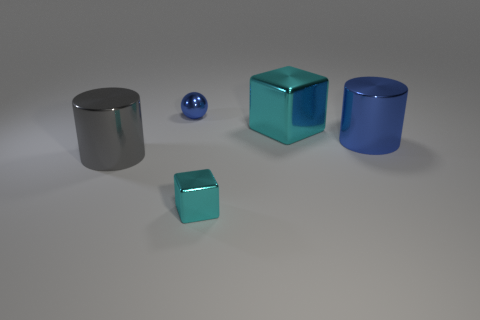How many things are in front of the metal cylinder that is in front of the cylinder behind the big gray object?
Ensure brevity in your answer.  1. Do the large blue object to the right of the blue metallic sphere and the cyan cube right of the tiny cyan shiny cube have the same material?
Your response must be concise. Yes. What is the material of the large object that is the same color as the sphere?
Ensure brevity in your answer.  Metal. How many other large metal objects have the same shape as the big blue object?
Provide a succinct answer. 1. Are there more small cyan metal things on the right side of the large cyan thing than small blocks?
Ensure brevity in your answer.  No. There is a thing that is in front of the cylinder left of the tiny metallic thing behind the large cyan metallic block; what shape is it?
Offer a terse response. Cube. There is a tiny shiny object that is behind the small cyan object; is it the same shape as the tiny object in front of the big gray cylinder?
Your answer should be very brief. No. Are there any other things that are the same size as the blue metallic cylinder?
Keep it short and to the point. Yes. What number of blocks are small cyan things or blue objects?
Keep it short and to the point. 1. Does the tiny cyan thing have the same material as the blue sphere?
Offer a terse response. Yes. 